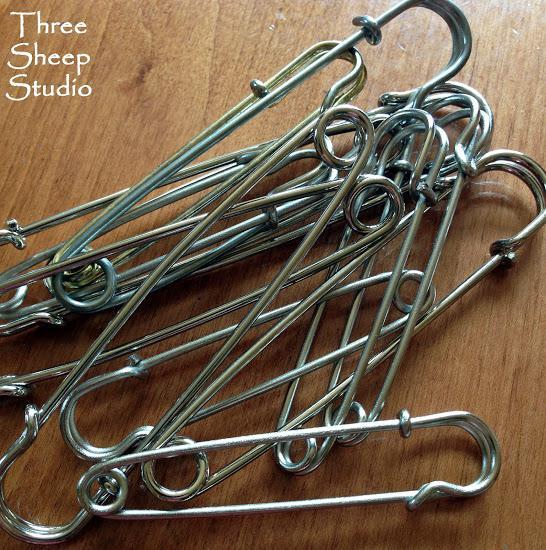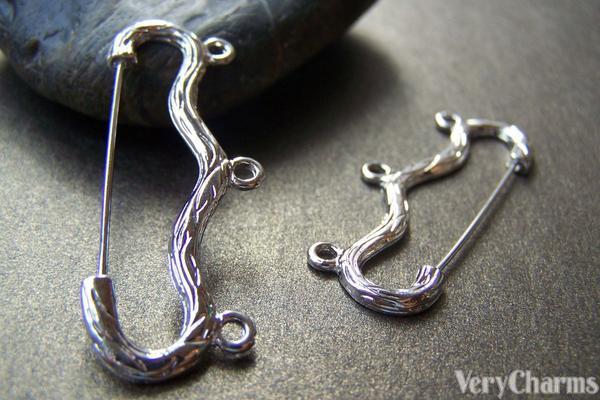The first image is the image on the left, the second image is the image on the right. Analyze the images presented: Is the assertion "there is at least one ribbon tied in a bow with bobby pins on a wooden surface" valid? Answer yes or no. No. The first image is the image on the left, the second image is the image on the right. Assess this claim about the two images: "Some safety pins have letters and numbers on them.". Correct or not? Answer yes or no. No. 